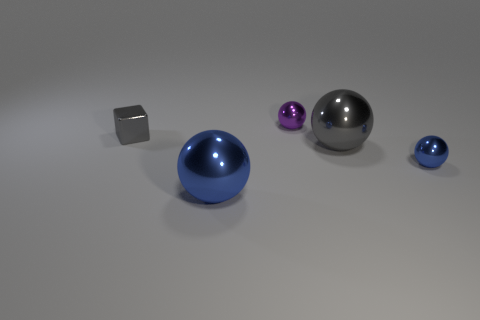Subtract 1 balls. How many balls are left? 3 Add 2 big brown matte blocks. How many objects exist? 7 Subtract all cubes. How many objects are left? 4 Subtract all small green shiny balls. Subtract all blue balls. How many objects are left? 3 Add 1 small objects. How many small objects are left? 4 Add 5 purple things. How many purple things exist? 6 Subtract 1 gray cubes. How many objects are left? 4 